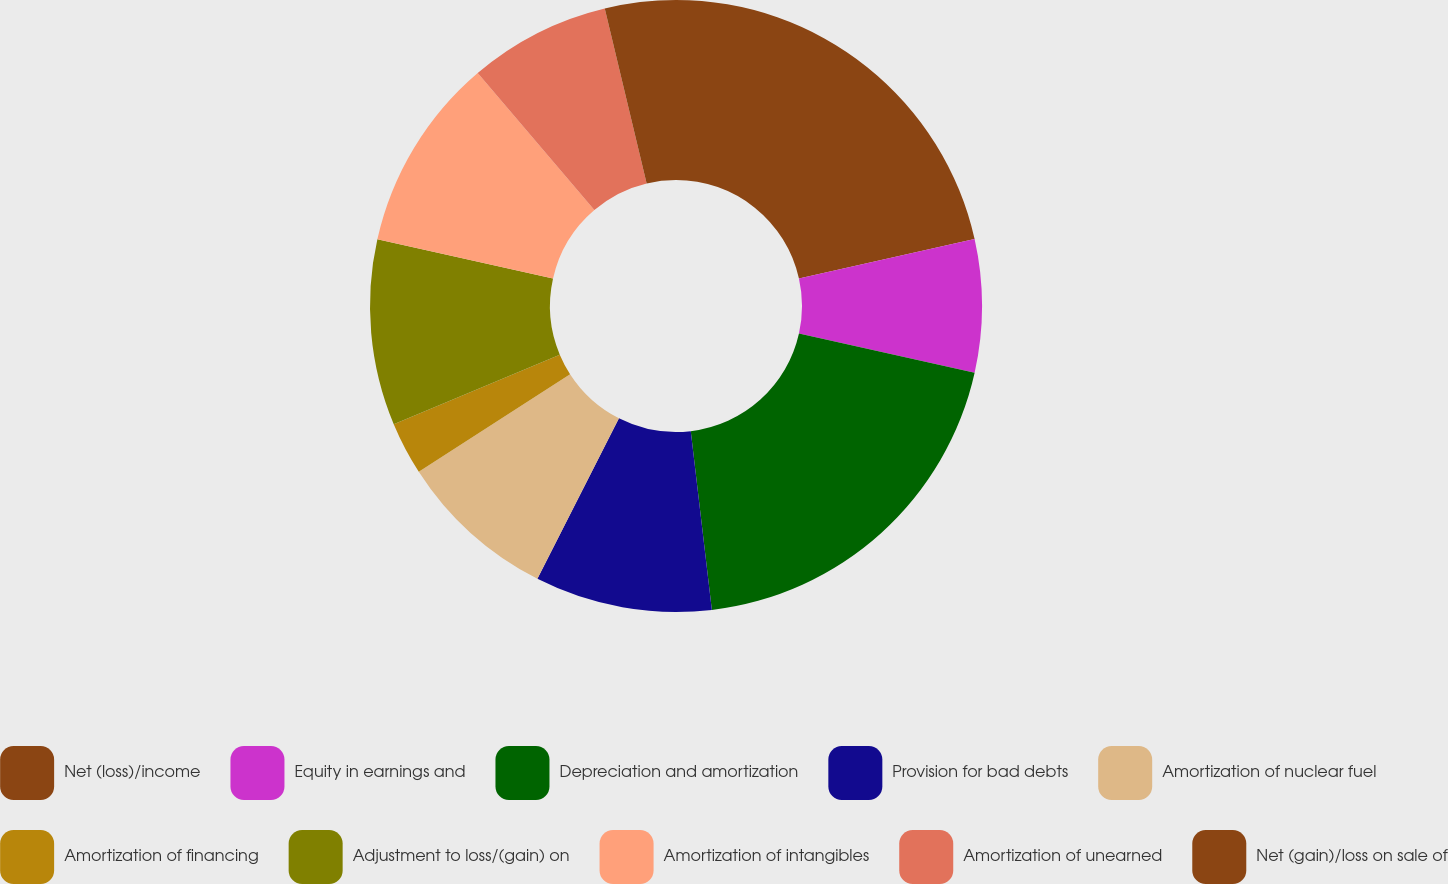Convert chart to OTSL. <chart><loc_0><loc_0><loc_500><loc_500><pie_chart><fcel>Net (loss)/income<fcel>Equity in earnings and<fcel>Depreciation and amortization<fcel>Provision for bad debts<fcel>Amortization of nuclear fuel<fcel>Amortization of financing<fcel>Adjustment to loss/(gain) on<fcel>Amortization of intangibles<fcel>Amortization of unearned<fcel>Net (gain)/loss on sale of<nl><fcel>21.49%<fcel>7.01%<fcel>19.63%<fcel>9.35%<fcel>8.41%<fcel>2.8%<fcel>9.81%<fcel>10.28%<fcel>7.48%<fcel>3.74%<nl></chart> 